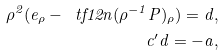Convert formula to latex. <formula><loc_0><loc_0><loc_500><loc_500>\rho ^ { 2 } ( e _ { \rho } - \ t f { 1 } { 2 } n ( \rho ^ { - 1 } P ) _ { \rho } ) = d , \\ c ^ { \prime } d = - a ,</formula> 